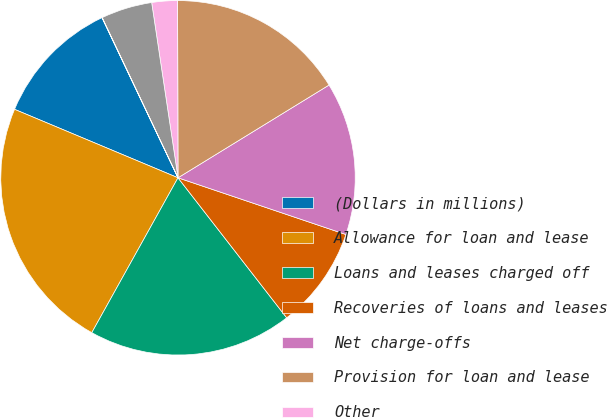Convert chart. <chart><loc_0><loc_0><loc_500><loc_500><pie_chart><fcel>(Dollars in millions)<fcel>Allowance for loan and lease<fcel>Loans and leases charged off<fcel>Recoveries of loans and leases<fcel>Net charge-offs<fcel>Provision for loan and lease<fcel>Other<fcel>Reserve for unfunded lending<fcel>Provision for unfunded lending<nl><fcel>11.63%<fcel>23.23%<fcel>18.59%<fcel>9.31%<fcel>13.95%<fcel>16.27%<fcel>2.34%<fcel>4.66%<fcel>0.02%<nl></chart> 